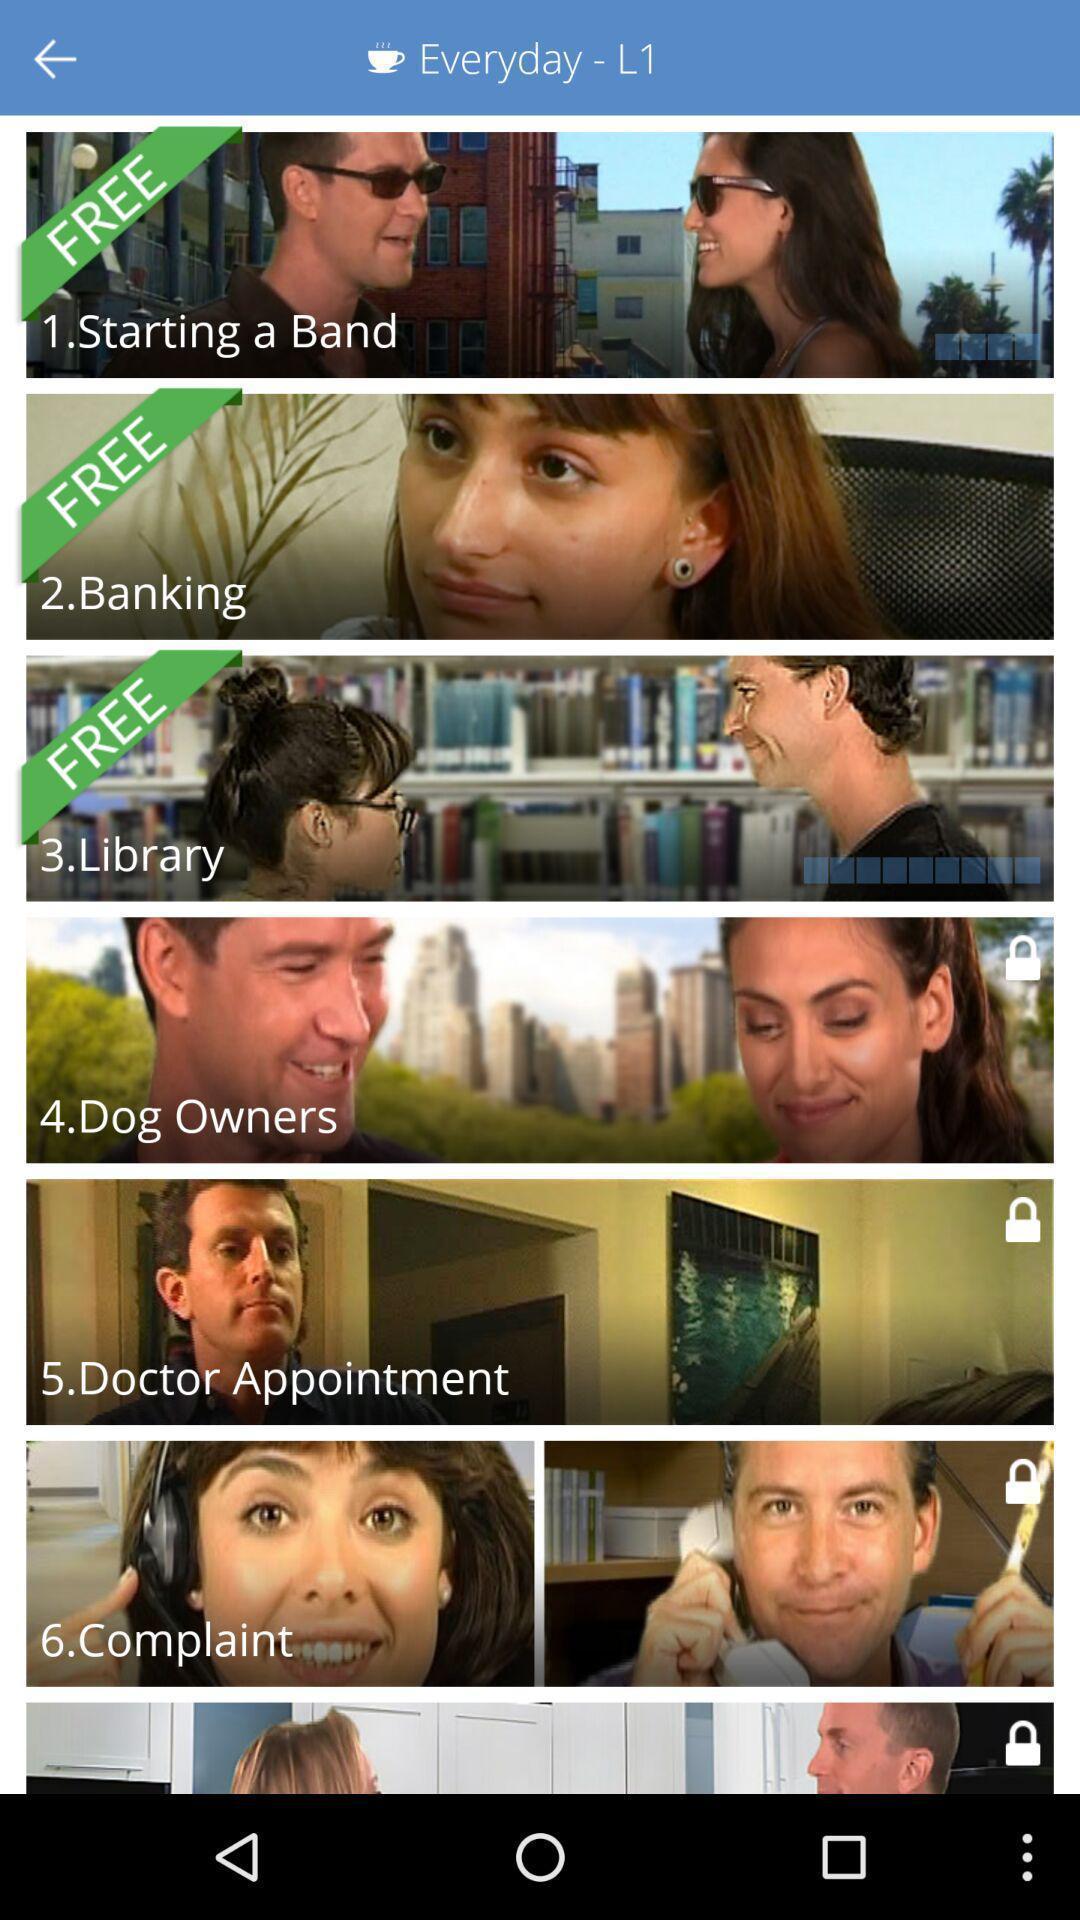Provide a detailed account of this screenshot. Screen shows videos from a language learning app. 